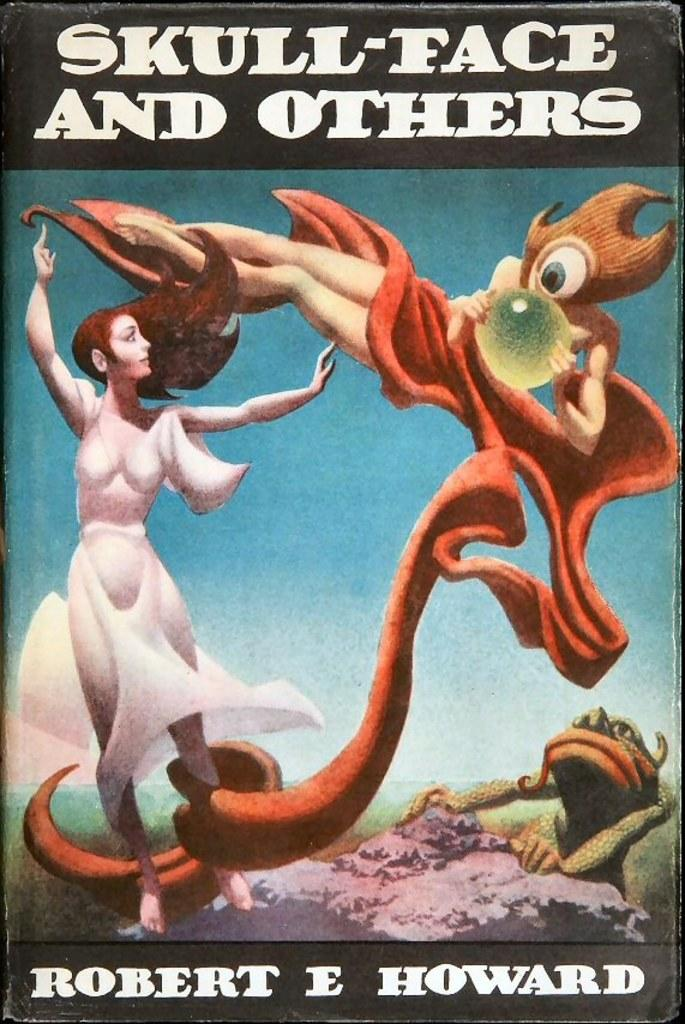<image>
Present a compact description of the photo's key features. a book that says skull face and others 